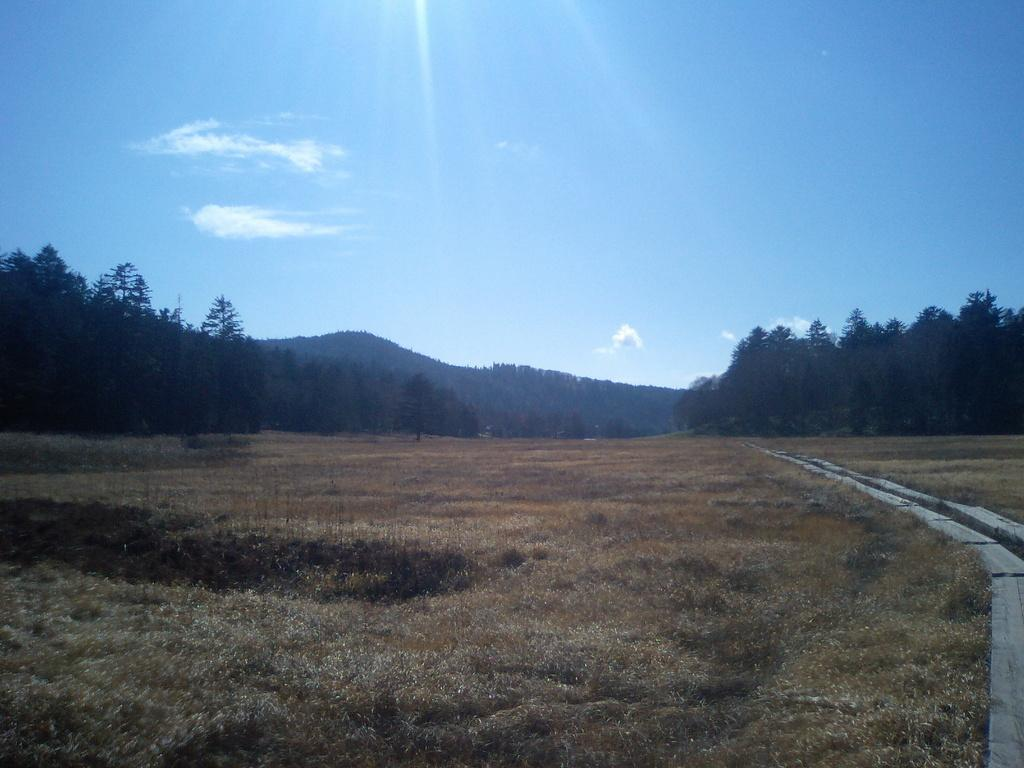What type of vegetation is in the foreground of the image? There is grass in the foreground of the image. What type of natural features can be seen in the background of the image? There are mountains and trees in the background of the image. What is visible at the top of the image? The sky is visible at the top of the image. How many oranges are scattered on the grass in the image? There are no oranges present in the image; it features grass, mountains, trees, and the sky. Is there any popcorn visible on the mountains in the image? There is no popcorn present in the image; it features grass, mountains, trees, and the sky. 